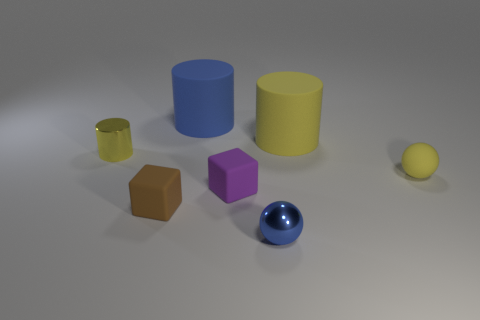Add 3 big blue rubber objects. How many objects exist? 10 Subtract 1 spheres. How many spheres are left? 1 Subtract all big cylinders. How many cylinders are left? 1 Add 6 blue shiny spheres. How many blue shiny spheres are left? 7 Add 5 large matte objects. How many large matte objects exist? 7 Subtract all blue cylinders. How many cylinders are left? 2 Subtract 1 blue cylinders. How many objects are left? 6 Subtract all balls. How many objects are left? 5 Subtract all cyan cylinders. Subtract all cyan balls. How many cylinders are left? 3 Subtract all cyan cubes. How many brown balls are left? 0 